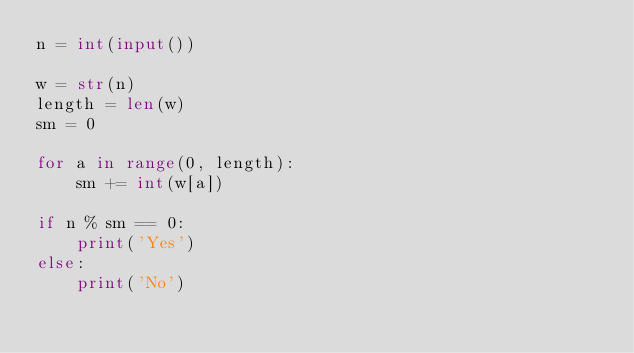Convert code to text. <code><loc_0><loc_0><loc_500><loc_500><_Python_>n = int(input())

w = str(n)
length = len(w)
sm = 0

for a in range(0, length):
    sm += int(w[a])

if n % sm == 0:
    print('Yes')
else:
    print('No')
</code> 